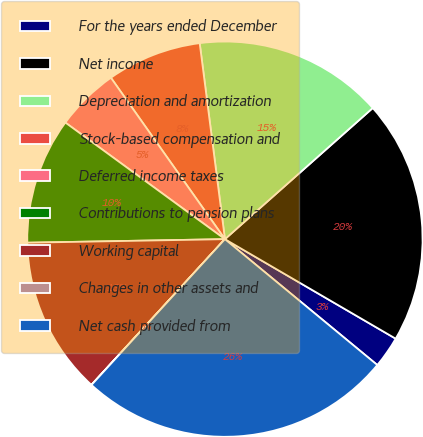Convert chart. <chart><loc_0><loc_0><loc_500><loc_500><pie_chart><fcel>For the years ended December<fcel>Net income<fcel>Depreciation and amortization<fcel>Stock-based compensation and<fcel>Deferred income taxes<fcel>Contributions to pension plans<fcel>Working capital<fcel>Changes in other assets and<fcel>Net cash provided from<nl><fcel>2.59%<fcel>19.95%<fcel>15.49%<fcel>7.75%<fcel>5.17%<fcel>10.33%<fcel>12.91%<fcel>0.01%<fcel>25.81%<nl></chart> 